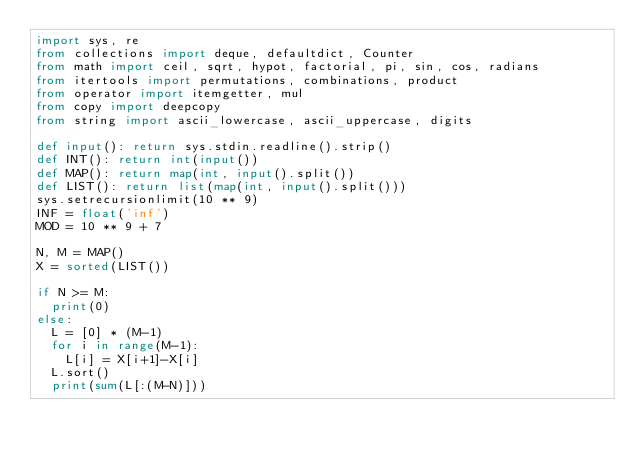<code> <loc_0><loc_0><loc_500><loc_500><_Python_>import sys, re
from collections import deque, defaultdict, Counter
from math import ceil, sqrt, hypot, factorial, pi, sin, cos, radians
from itertools import permutations, combinations, product
from operator import itemgetter, mul
from copy import deepcopy
from string import ascii_lowercase, ascii_uppercase, digits

def input(): return sys.stdin.readline().strip()
def INT(): return int(input())
def MAP(): return map(int, input().split())
def LIST(): return list(map(int, input().split()))
sys.setrecursionlimit(10 ** 9)
INF = float('inf')
MOD = 10 ** 9 + 7

N, M = MAP()
X = sorted(LIST())

if N >= M:
	print(0)
else:
	L = [0] * (M-1)
	for i in range(M-1):
		L[i] = X[i+1]-X[i]
	L.sort()
	print(sum(L[:(M-N)]))
</code> 